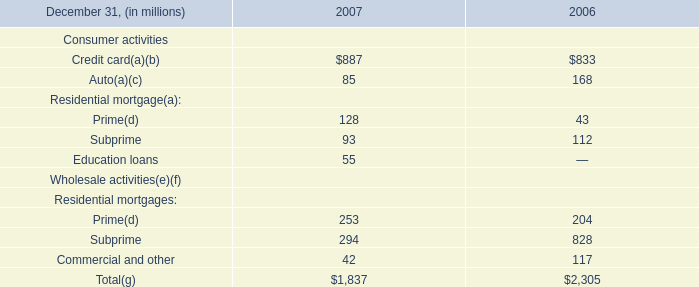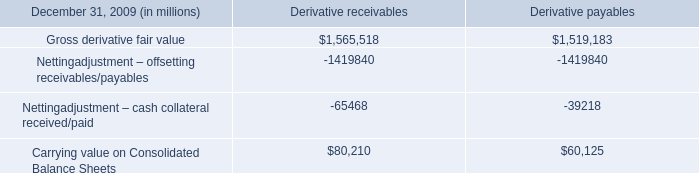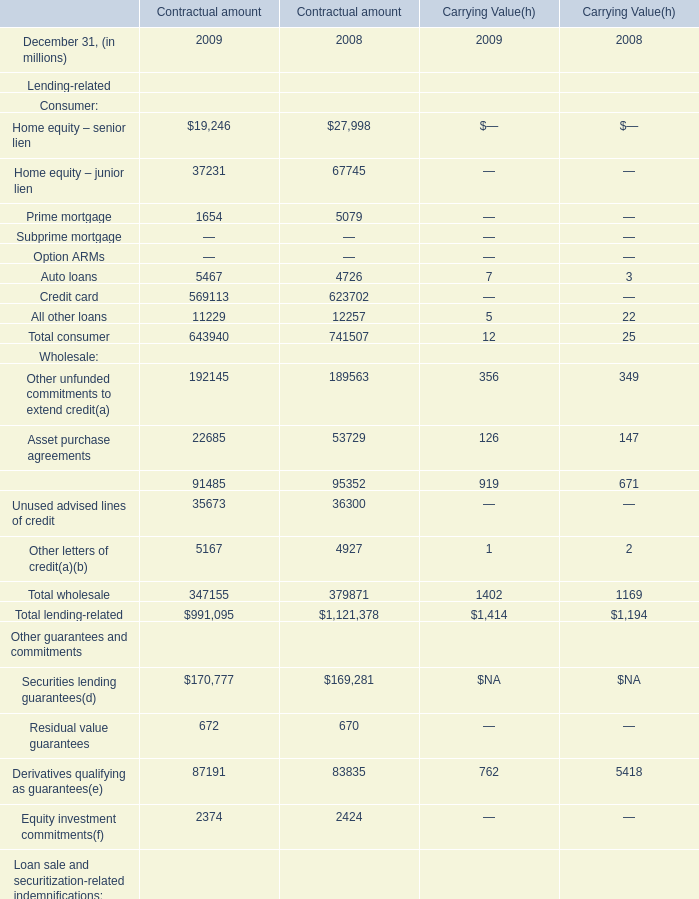What is the total amount of Home equity – senior lien of Contractual amount 2008, and Carrying value on Consolidated Balance Sheets of Derivative receivables ? 
Computations: (27998.0 + 80210.0)
Answer: 108208.0. 